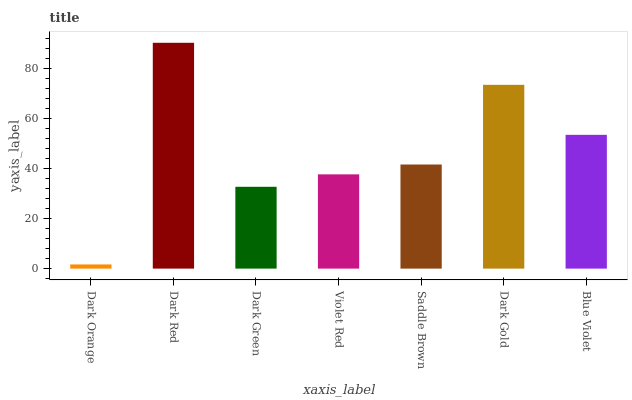Is Dark Orange the minimum?
Answer yes or no. Yes. Is Dark Red the maximum?
Answer yes or no. Yes. Is Dark Green the minimum?
Answer yes or no. No. Is Dark Green the maximum?
Answer yes or no. No. Is Dark Red greater than Dark Green?
Answer yes or no. Yes. Is Dark Green less than Dark Red?
Answer yes or no. Yes. Is Dark Green greater than Dark Red?
Answer yes or no. No. Is Dark Red less than Dark Green?
Answer yes or no. No. Is Saddle Brown the high median?
Answer yes or no. Yes. Is Saddle Brown the low median?
Answer yes or no. Yes. Is Dark Gold the high median?
Answer yes or no. No. Is Dark Green the low median?
Answer yes or no. No. 